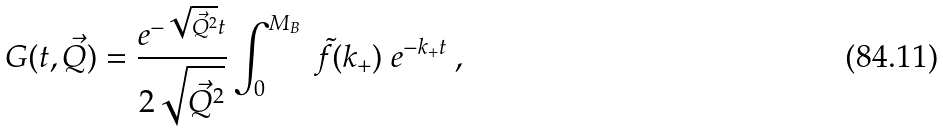Convert formula to latex. <formula><loc_0><loc_0><loc_500><loc_500>G ( t , \vec { Q } ) = \frac { e ^ { - \sqrt { \vec { Q } ^ { 2 } } t } } { 2 \sqrt { \vec { Q } ^ { 2 } } } \int ^ { M _ { B } } _ { 0 } \ \tilde { f } ( k _ { + } ) \ e ^ { - k _ { + } t } \ ,</formula> 